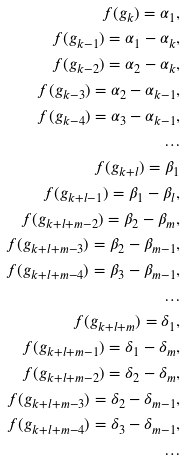<formula> <loc_0><loc_0><loc_500><loc_500>f ( g _ { k } ) = \alpha _ { 1 } , \\ f ( g _ { k - 1 } ) = \alpha _ { 1 } - \alpha _ { k } , \\ f ( g _ { k - 2 } ) = \alpha _ { 2 } - \alpha _ { k } , \\ f ( g _ { k - 3 } ) = \alpha _ { 2 } - \alpha _ { k - 1 } , \\ f ( g _ { k - 4 } ) = \alpha _ { 3 } - \alpha _ { k - 1 } , \\ \dots \\ f ( g _ { k + l } ) = \beta _ { 1 } \\ f ( g _ { k + l - 1 } ) = \beta _ { 1 } - \beta _ { l } , \\ f ( g _ { k + l + m - 2 } ) = \beta _ { 2 } - \beta _ { m } , \\ f ( g _ { k + l + m - 3 } ) = \beta _ { 2 } - \beta _ { m - 1 } , \\ f ( g _ { k + l + m - 4 } ) = \beta _ { 3 } - \beta _ { m - 1 } , \\ \dots \\ f ( g _ { k + l + m } ) = \delta _ { 1 } , \\ f ( g _ { k + l + m - 1 } ) = \delta _ { 1 } - \delta _ { m } , \\ f ( g _ { k + l + m - 2 } ) = \delta _ { 2 } - \delta _ { m } , \\ f ( g _ { k + l + m - 3 } ) = \delta _ { 2 } - \delta _ { m - 1 } , \\ f ( g _ { k + l + m - 4 } ) = \delta _ { 3 } - \delta _ { m - 1 } , \\ \dots</formula> 